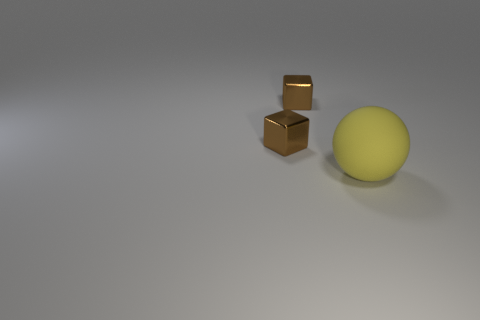How many blue objects are either tiny cubes or matte things?
Ensure brevity in your answer.  0. What number of other objects are there of the same size as the yellow rubber thing?
Provide a short and direct response. 0. How many large matte cylinders are there?
Offer a terse response. 0. Are there any other things that have the same shape as the yellow thing?
Make the answer very short. No. What is the material of the yellow ball?
Offer a terse response. Rubber. What number of matte things are either big yellow objects or cubes?
Your answer should be compact. 1. What number of small objects have the same color as the big thing?
Make the answer very short. 0. How many tiny things are either brown objects or matte things?
Keep it short and to the point. 2. Is there a metal object that has the same size as the matte sphere?
Your answer should be compact. No. Is the number of yellow objects behind the rubber sphere the same as the number of big matte balls?
Your answer should be compact. No. 